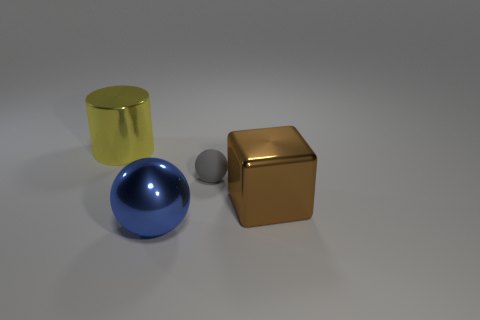There is a metal object right of the shiny sphere; what size is it?
Your answer should be compact. Large. How many yellow objects have the same material as the large brown block?
Keep it short and to the point. 1. There is a large object that is to the right of the gray matte ball; is its shape the same as the big blue shiny object?
Provide a short and direct response. No. The cube that is the same material as the yellow object is what color?
Ensure brevity in your answer.  Brown. Is there a large blue metal ball that is to the right of the sphere to the left of the gray ball that is to the left of the brown metallic object?
Make the answer very short. No. There is a brown metal thing; what shape is it?
Give a very brief answer. Cube. Are there fewer brown things that are on the left side of the tiny rubber object than gray balls?
Give a very brief answer. Yes. Are there any large purple shiny objects of the same shape as the yellow thing?
Give a very brief answer. No. What is the shape of the blue object that is the same size as the cylinder?
Your answer should be compact. Sphere. What number of objects are either metallic cubes or big purple cylinders?
Your response must be concise. 1. 